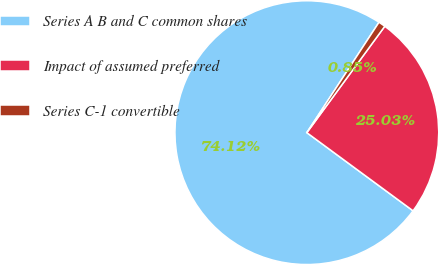<chart> <loc_0><loc_0><loc_500><loc_500><pie_chart><fcel>Series A B and C common shares<fcel>Impact of assumed preferred<fcel>Series C-1 convertible<nl><fcel>74.12%<fcel>25.03%<fcel>0.85%<nl></chart> 